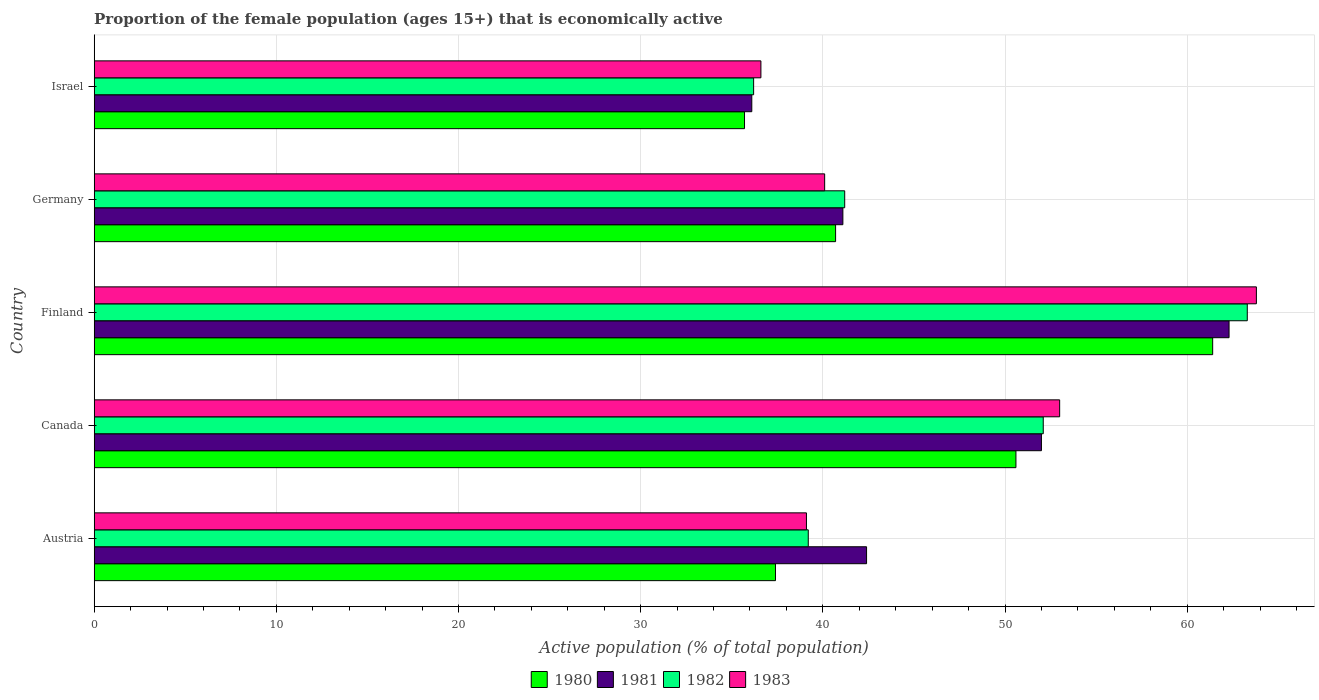How many different coloured bars are there?
Give a very brief answer. 4. Are the number of bars per tick equal to the number of legend labels?
Give a very brief answer. Yes. Are the number of bars on each tick of the Y-axis equal?
Provide a succinct answer. Yes. How many bars are there on the 2nd tick from the bottom?
Give a very brief answer. 4. What is the label of the 5th group of bars from the top?
Your answer should be compact. Austria. In how many cases, is the number of bars for a given country not equal to the number of legend labels?
Your answer should be compact. 0. What is the proportion of the female population that is economically active in 1983 in Germany?
Ensure brevity in your answer.  40.1. Across all countries, what is the maximum proportion of the female population that is economically active in 1981?
Ensure brevity in your answer.  62.3. Across all countries, what is the minimum proportion of the female population that is economically active in 1982?
Your response must be concise. 36.2. In which country was the proportion of the female population that is economically active in 1983 maximum?
Your answer should be very brief. Finland. In which country was the proportion of the female population that is economically active in 1983 minimum?
Provide a short and direct response. Israel. What is the total proportion of the female population that is economically active in 1982 in the graph?
Ensure brevity in your answer.  232. What is the difference between the proportion of the female population that is economically active in 1983 in Austria and that in Finland?
Give a very brief answer. -24.7. What is the difference between the proportion of the female population that is economically active in 1983 in Israel and the proportion of the female population that is economically active in 1981 in Canada?
Provide a succinct answer. -15.4. What is the average proportion of the female population that is economically active in 1983 per country?
Your answer should be very brief. 46.52. What is the ratio of the proportion of the female population that is economically active in 1981 in Canada to that in Finland?
Keep it short and to the point. 0.83. Is the difference between the proportion of the female population that is economically active in 1980 in Finland and Israel greater than the difference between the proportion of the female population that is economically active in 1981 in Finland and Israel?
Your answer should be very brief. No. What is the difference between the highest and the second highest proportion of the female population that is economically active in 1981?
Your answer should be compact. 10.3. What is the difference between the highest and the lowest proportion of the female population that is economically active in 1981?
Give a very brief answer. 26.2. In how many countries, is the proportion of the female population that is economically active in 1982 greater than the average proportion of the female population that is economically active in 1982 taken over all countries?
Your answer should be compact. 2. Is the sum of the proportion of the female population that is economically active in 1980 in Canada and Germany greater than the maximum proportion of the female population that is economically active in 1981 across all countries?
Your answer should be very brief. Yes. Is it the case that in every country, the sum of the proportion of the female population that is economically active in 1983 and proportion of the female population that is economically active in 1981 is greater than the sum of proportion of the female population that is economically active in 1982 and proportion of the female population that is economically active in 1980?
Your response must be concise. No. What does the 2nd bar from the bottom in Austria represents?
Keep it short and to the point. 1981. Are all the bars in the graph horizontal?
Provide a succinct answer. Yes. Does the graph contain grids?
Provide a succinct answer. Yes. What is the title of the graph?
Your response must be concise. Proportion of the female population (ages 15+) that is economically active. Does "2009" appear as one of the legend labels in the graph?
Provide a succinct answer. No. What is the label or title of the X-axis?
Offer a terse response. Active population (% of total population). What is the label or title of the Y-axis?
Your answer should be compact. Country. What is the Active population (% of total population) of 1980 in Austria?
Keep it short and to the point. 37.4. What is the Active population (% of total population) in 1981 in Austria?
Offer a terse response. 42.4. What is the Active population (% of total population) of 1982 in Austria?
Offer a very short reply. 39.2. What is the Active population (% of total population) in 1983 in Austria?
Your answer should be very brief. 39.1. What is the Active population (% of total population) of 1980 in Canada?
Make the answer very short. 50.6. What is the Active population (% of total population) of 1981 in Canada?
Give a very brief answer. 52. What is the Active population (% of total population) of 1982 in Canada?
Give a very brief answer. 52.1. What is the Active population (% of total population) in 1983 in Canada?
Your answer should be very brief. 53. What is the Active population (% of total population) in 1980 in Finland?
Give a very brief answer. 61.4. What is the Active population (% of total population) in 1981 in Finland?
Make the answer very short. 62.3. What is the Active population (% of total population) of 1982 in Finland?
Keep it short and to the point. 63.3. What is the Active population (% of total population) of 1983 in Finland?
Your answer should be compact. 63.8. What is the Active population (% of total population) of 1980 in Germany?
Your answer should be compact. 40.7. What is the Active population (% of total population) of 1981 in Germany?
Make the answer very short. 41.1. What is the Active population (% of total population) of 1982 in Germany?
Give a very brief answer. 41.2. What is the Active population (% of total population) of 1983 in Germany?
Your answer should be compact. 40.1. What is the Active population (% of total population) of 1980 in Israel?
Your response must be concise. 35.7. What is the Active population (% of total population) of 1981 in Israel?
Your answer should be very brief. 36.1. What is the Active population (% of total population) in 1982 in Israel?
Ensure brevity in your answer.  36.2. What is the Active population (% of total population) of 1983 in Israel?
Your answer should be compact. 36.6. Across all countries, what is the maximum Active population (% of total population) of 1980?
Offer a terse response. 61.4. Across all countries, what is the maximum Active population (% of total population) of 1981?
Make the answer very short. 62.3. Across all countries, what is the maximum Active population (% of total population) of 1982?
Your response must be concise. 63.3. Across all countries, what is the maximum Active population (% of total population) of 1983?
Provide a succinct answer. 63.8. Across all countries, what is the minimum Active population (% of total population) in 1980?
Keep it short and to the point. 35.7. Across all countries, what is the minimum Active population (% of total population) in 1981?
Your answer should be compact. 36.1. Across all countries, what is the minimum Active population (% of total population) of 1982?
Offer a very short reply. 36.2. Across all countries, what is the minimum Active population (% of total population) in 1983?
Your response must be concise. 36.6. What is the total Active population (% of total population) in 1980 in the graph?
Give a very brief answer. 225.8. What is the total Active population (% of total population) in 1981 in the graph?
Your response must be concise. 233.9. What is the total Active population (% of total population) in 1982 in the graph?
Keep it short and to the point. 232. What is the total Active population (% of total population) in 1983 in the graph?
Provide a short and direct response. 232.6. What is the difference between the Active population (% of total population) of 1980 in Austria and that in Canada?
Your answer should be compact. -13.2. What is the difference between the Active population (% of total population) in 1982 in Austria and that in Canada?
Provide a short and direct response. -12.9. What is the difference between the Active population (% of total population) in 1980 in Austria and that in Finland?
Keep it short and to the point. -24. What is the difference between the Active population (% of total population) in 1981 in Austria and that in Finland?
Your answer should be compact. -19.9. What is the difference between the Active population (% of total population) of 1982 in Austria and that in Finland?
Give a very brief answer. -24.1. What is the difference between the Active population (% of total population) of 1983 in Austria and that in Finland?
Offer a very short reply. -24.7. What is the difference between the Active population (% of total population) of 1982 in Austria and that in Germany?
Ensure brevity in your answer.  -2. What is the difference between the Active population (% of total population) in 1980 in Austria and that in Israel?
Offer a terse response. 1.7. What is the difference between the Active population (% of total population) of 1981 in Austria and that in Israel?
Keep it short and to the point. 6.3. What is the difference between the Active population (% of total population) of 1980 in Canada and that in Finland?
Your answer should be very brief. -10.8. What is the difference between the Active population (% of total population) in 1983 in Canada and that in Finland?
Give a very brief answer. -10.8. What is the difference between the Active population (% of total population) of 1981 in Canada and that in Germany?
Ensure brevity in your answer.  10.9. What is the difference between the Active population (% of total population) in 1983 in Canada and that in Germany?
Provide a succinct answer. 12.9. What is the difference between the Active population (% of total population) of 1980 in Canada and that in Israel?
Provide a short and direct response. 14.9. What is the difference between the Active population (% of total population) in 1982 in Canada and that in Israel?
Keep it short and to the point. 15.9. What is the difference between the Active population (% of total population) of 1983 in Canada and that in Israel?
Offer a terse response. 16.4. What is the difference between the Active population (% of total population) in 1980 in Finland and that in Germany?
Offer a terse response. 20.7. What is the difference between the Active population (% of total population) in 1981 in Finland and that in Germany?
Make the answer very short. 21.2. What is the difference between the Active population (% of total population) in 1982 in Finland and that in Germany?
Give a very brief answer. 22.1. What is the difference between the Active population (% of total population) in 1983 in Finland and that in Germany?
Keep it short and to the point. 23.7. What is the difference between the Active population (% of total population) in 1980 in Finland and that in Israel?
Keep it short and to the point. 25.7. What is the difference between the Active population (% of total population) in 1981 in Finland and that in Israel?
Make the answer very short. 26.2. What is the difference between the Active population (% of total population) in 1982 in Finland and that in Israel?
Offer a terse response. 27.1. What is the difference between the Active population (% of total population) of 1983 in Finland and that in Israel?
Give a very brief answer. 27.2. What is the difference between the Active population (% of total population) in 1981 in Germany and that in Israel?
Your answer should be very brief. 5. What is the difference between the Active population (% of total population) of 1980 in Austria and the Active population (% of total population) of 1981 in Canada?
Make the answer very short. -14.6. What is the difference between the Active population (% of total population) in 1980 in Austria and the Active population (% of total population) in 1982 in Canada?
Provide a succinct answer. -14.7. What is the difference between the Active population (% of total population) in 1980 in Austria and the Active population (% of total population) in 1983 in Canada?
Provide a succinct answer. -15.6. What is the difference between the Active population (% of total population) of 1981 in Austria and the Active population (% of total population) of 1983 in Canada?
Keep it short and to the point. -10.6. What is the difference between the Active population (% of total population) of 1980 in Austria and the Active population (% of total population) of 1981 in Finland?
Keep it short and to the point. -24.9. What is the difference between the Active population (% of total population) of 1980 in Austria and the Active population (% of total population) of 1982 in Finland?
Your answer should be very brief. -25.9. What is the difference between the Active population (% of total population) of 1980 in Austria and the Active population (% of total population) of 1983 in Finland?
Make the answer very short. -26.4. What is the difference between the Active population (% of total population) of 1981 in Austria and the Active population (% of total population) of 1982 in Finland?
Your answer should be very brief. -20.9. What is the difference between the Active population (% of total population) in 1981 in Austria and the Active population (% of total population) in 1983 in Finland?
Your answer should be compact. -21.4. What is the difference between the Active population (% of total population) in 1982 in Austria and the Active population (% of total population) in 1983 in Finland?
Your answer should be very brief. -24.6. What is the difference between the Active population (% of total population) in 1980 in Austria and the Active population (% of total population) in 1981 in Germany?
Ensure brevity in your answer.  -3.7. What is the difference between the Active population (% of total population) in 1980 in Austria and the Active population (% of total population) in 1983 in Germany?
Give a very brief answer. -2.7. What is the difference between the Active population (% of total population) in 1981 in Austria and the Active population (% of total population) in 1982 in Germany?
Keep it short and to the point. 1.2. What is the difference between the Active population (% of total population) of 1981 in Austria and the Active population (% of total population) of 1983 in Germany?
Make the answer very short. 2.3. What is the difference between the Active population (% of total population) of 1982 in Austria and the Active population (% of total population) of 1983 in Germany?
Make the answer very short. -0.9. What is the difference between the Active population (% of total population) of 1980 in Austria and the Active population (% of total population) of 1981 in Israel?
Offer a terse response. 1.3. What is the difference between the Active population (% of total population) in 1980 in Austria and the Active population (% of total population) in 1982 in Israel?
Provide a short and direct response. 1.2. What is the difference between the Active population (% of total population) in 1982 in Austria and the Active population (% of total population) in 1983 in Israel?
Offer a terse response. 2.6. What is the difference between the Active population (% of total population) of 1980 in Canada and the Active population (% of total population) of 1981 in Finland?
Provide a short and direct response. -11.7. What is the difference between the Active population (% of total population) of 1980 in Canada and the Active population (% of total population) of 1982 in Finland?
Your answer should be very brief. -12.7. What is the difference between the Active population (% of total population) of 1980 in Canada and the Active population (% of total population) of 1983 in Finland?
Provide a succinct answer. -13.2. What is the difference between the Active population (% of total population) in 1981 in Canada and the Active population (% of total population) in 1982 in Finland?
Ensure brevity in your answer.  -11.3. What is the difference between the Active population (% of total population) in 1980 in Canada and the Active population (% of total population) in 1981 in Germany?
Keep it short and to the point. 9.5. What is the difference between the Active population (% of total population) in 1980 in Canada and the Active population (% of total population) in 1982 in Germany?
Offer a very short reply. 9.4. What is the difference between the Active population (% of total population) of 1980 in Canada and the Active population (% of total population) of 1983 in Germany?
Offer a terse response. 10.5. What is the difference between the Active population (% of total population) of 1981 in Canada and the Active population (% of total population) of 1983 in Germany?
Provide a short and direct response. 11.9. What is the difference between the Active population (% of total population) of 1980 in Canada and the Active population (% of total population) of 1981 in Israel?
Make the answer very short. 14.5. What is the difference between the Active population (% of total population) in 1980 in Canada and the Active population (% of total population) in 1982 in Israel?
Your answer should be compact. 14.4. What is the difference between the Active population (% of total population) in 1980 in Canada and the Active population (% of total population) in 1983 in Israel?
Keep it short and to the point. 14. What is the difference between the Active population (% of total population) of 1982 in Canada and the Active population (% of total population) of 1983 in Israel?
Give a very brief answer. 15.5. What is the difference between the Active population (% of total population) in 1980 in Finland and the Active population (% of total population) in 1981 in Germany?
Provide a short and direct response. 20.3. What is the difference between the Active population (% of total population) in 1980 in Finland and the Active population (% of total population) in 1982 in Germany?
Keep it short and to the point. 20.2. What is the difference between the Active population (% of total population) in 1980 in Finland and the Active population (% of total population) in 1983 in Germany?
Offer a terse response. 21.3. What is the difference between the Active population (% of total population) of 1981 in Finland and the Active population (% of total population) of 1982 in Germany?
Ensure brevity in your answer.  21.1. What is the difference between the Active population (% of total population) in 1981 in Finland and the Active population (% of total population) in 1983 in Germany?
Your response must be concise. 22.2. What is the difference between the Active population (% of total population) in 1982 in Finland and the Active population (% of total population) in 1983 in Germany?
Keep it short and to the point. 23.2. What is the difference between the Active population (% of total population) of 1980 in Finland and the Active population (% of total population) of 1981 in Israel?
Ensure brevity in your answer.  25.3. What is the difference between the Active population (% of total population) of 1980 in Finland and the Active population (% of total population) of 1982 in Israel?
Ensure brevity in your answer.  25.2. What is the difference between the Active population (% of total population) of 1980 in Finland and the Active population (% of total population) of 1983 in Israel?
Give a very brief answer. 24.8. What is the difference between the Active population (% of total population) of 1981 in Finland and the Active population (% of total population) of 1982 in Israel?
Make the answer very short. 26.1. What is the difference between the Active population (% of total population) in 1981 in Finland and the Active population (% of total population) in 1983 in Israel?
Your answer should be very brief. 25.7. What is the difference between the Active population (% of total population) in 1982 in Finland and the Active population (% of total population) in 1983 in Israel?
Keep it short and to the point. 26.7. What is the difference between the Active population (% of total population) of 1981 in Germany and the Active population (% of total population) of 1983 in Israel?
Your answer should be compact. 4.5. What is the difference between the Active population (% of total population) in 1982 in Germany and the Active population (% of total population) in 1983 in Israel?
Keep it short and to the point. 4.6. What is the average Active population (% of total population) of 1980 per country?
Offer a very short reply. 45.16. What is the average Active population (% of total population) of 1981 per country?
Provide a short and direct response. 46.78. What is the average Active population (% of total population) in 1982 per country?
Keep it short and to the point. 46.4. What is the average Active population (% of total population) in 1983 per country?
Your response must be concise. 46.52. What is the difference between the Active population (% of total population) in 1981 and Active population (% of total population) in 1982 in Austria?
Offer a terse response. 3.2. What is the difference between the Active population (% of total population) of 1981 and Active population (% of total population) of 1983 in Austria?
Your answer should be very brief. 3.3. What is the difference between the Active population (% of total population) in 1980 and Active population (% of total population) in 1981 in Canada?
Your answer should be very brief. -1.4. What is the difference between the Active population (% of total population) of 1981 and Active population (% of total population) of 1983 in Canada?
Offer a terse response. -1. What is the difference between the Active population (% of total population) of 1982 and Active population (% of total population) of 1983 in Canada?
Provide a short and direct response. -0.9. What is the difference between the Active population (% of total population) in 1981 and Active population (% of total population) in 1983 in Finland?
Make the answer very short. -1.5. What is the difference between the Active population (% of total population) in 1980 and Active population (% of total population) in 1981 in Germany?
Your response must be concise. -0.4. What is the difference between the Active population (% of total population) in 1980 and Active population (% of total population) in 1983 in Germany?
Your answer should be compact. 0.6. What is the difference between the Active population (% of total population) of 1981 and Active population (% of total population) of 1982 in Germany?
Offer a terse response. -0.1. What is the difference between the Active population (% of total population) in 1982 and Active population (% of total population) in 1983 in Germany?
Offer a very short reply. 1.1. What is the difference between the Active population (% of total population) of 1980 and Active population (% of total population) of 1983 in Israel?
Provide a short and direct response. -0.9. What is the difference between the Active population (% of total population) of 1981 and Active population (% of total population) of 1982 in Israel?
Your answer should be compact. -0.1. What is the difference between the Active population (% of total population) of 1981 and Active population (% of total population) of 1983 in Israel?
Your answer should be very brief. -0.5. What is the difference between the Active population (% of total population) in 1982 and Active population (% of total population) in 1983 in Israel?
Keep it short and to the point. -0.4. What is the ratio of the Active population (% of total population) in 1980 in Austria to that in Canada?
Make the answer very short. 0.74. What is the ratio of the Active population (% of total population) in 1981 in Austria to that in Canada?
Offer a very short reply. 0.82. What is the ratio of the Active population (% of total population) in 1982 in Austria to that in Canada?
Give a very brief answer. 0.75. What is the ratio of the Active population (% of total population) of 1983 in Austria to that in Canada?
Offer a very short reply. 0.74. What is the ratio of the Active population (% of total population) of 1980 in Austria to that in Finland?
Make the answer very short. 0.61. What is the ratio of the Active population (% of total population) of 1981 in Austria to that in Finland?
Provide a succinct answer. 0.68. What is the ratio of the Active population (% of total population) of 1982 in Austria to that in Finland?
Your answer should be compact. 0.62. What is the ratio of the Active population (% of total population) of 1983 in Austria to that in Finland?
Keep it short and to the point. 0.61. What is the ratio of the Active population (% of total population) of 1980 in Austria to that in Germany?
Your answer should be very brief. 0.92. What is the ratio of the Active population (% of total population) in 1981 in Austria to that in Germany?
Ensure brevity in your answer.  1.03. What is the ratio of the Active population (% of total population) in 1982 in Austria to that in Germany?
Offer a terse response. 0.95. What is the ratio of the Active population (% of total population) in 1983 in Austria to that in Germany?
Your answer should be very brief. 0.98. What is the ratio of the Active population (% of total population) in 1980 in Austria to that in Israel?
Give a very brief answer. 1.05. What is the ratio of the Active population (% of total population) in 1981 in Austria to that in Israel?
Ensure brevity in your answer.  1.17. What is the ratio of the Active population (% of total population) of 1982 in Austria to that in Israel?
Provide a short and direct response. 1.08. What is the ratio of the Active population (% of total population) of 1983 in Austria to that in Israel?
Provide a succinct answer. 1.07. What is the ratio of the Active population (% of total population) in 1980 in Canada to that in Finland?
Make the answer very short. 0.82. What is the ratio of the Active population (% of total population) in 1981 in Canada to that in Finland?
Give a very brief answer. 0.83. What is the ratio of the Active population (% of total population) in 1982 in Canada to that in Finland?
Ensure brevity in your answer.  0.82. What is the ratio of the Active population (% of total population) of 1983 in Canada to that in Finland?
Offer a very short reply. 0.83. What is the ratio of the Active population (% of total population) of 1980 in Canada to that in Germany?
Make the answer very short. 1.24. What is the ratio of the Active population (% of total population) of 1981 in Canada to that in Germany?
Give a very brief answer. 1.27. What is the ratio of the Active population (% of total population) of 1982 in Canada to that in Germany?
Your answer should be compact. 1.26. What is the ratio of the Active population (% of total population) of 1983 in Canada to that in Germany?
Provide a succinct answer. 1.32. What is the ratio of the Active population (% of total population) in 1980 in Canada to that in Israel?
Give a very brief answer. 1.42. What is the ratio of the Active population (% of total population) in 1981 in Canada to that in Israel?
Your response must be concise. 1.44. What is the ratio of the Active population (% of total population) of 1982 in Canada to that in Israel?
Offer a very short reply. 1.44. What is the ratio of the Active population (% of total population) of 1983 in Canada to that in Israel?
Your answer should be compact. 1.45. What is the ratio of the Active population (% of total population) of 1980 in Finland to that in Germany?
Ensure brevity in your answer.  1.51. What is the ratio of the Active population (% of total population) in 1981 in Finland to that in Germany?
Offer a terse response. 1.52. What is the ratio of the Active population (% of total population) of 1982 in Finland to that in Germany?
Keep it short and to the point. 1.54. What is the ratio of the Active population (% of total population) in 1983 in Finland to that in Germany?
Provide a short and direct response. 1.59. What is the ratio of the Active population (% of total population) in 1980 in Finland to that in Israel?
Your answer should be compact. 1.72. What is the ratio of the Active population (% of total population) of 1981 in Finland to that in Israel?
Your response must be concise. 1.73. What is the ratio of the Active population (% of total population) of 1982 in Finland to that in Israel?
Make the answer very short. 1.75. What is the ratio of the Active population (% of total population) of 1983 in Finland to that in Israel?
Provide a short and direct response. 1.74. What is the ratio of the Active population (% of total population) in 1980 in Germany to that in Israel?
Keep it short and to the point. 1.14. What is the ratio of the Active population (% of total population) of 1981 in Germany to that in Israel?
Your answer should be very brief. 1.14. What is the ratio of the Active population (% of total population) in 1982 in Germany to that in Israel?
Offer a terse response. 1.14. What is the ratio of the Active population (% of total population) in 1983 in Germany to that in Israel?
Your answer should be compact. 1.1. What is the difference between the highest and the second highest Active population (% of total population) in 1980?
Make the answer very short. 10.8. What is the difference between the highest and the second highest Active population (% of total population) of 1982?
Provide a short and direct response. 11.2. What is the difference between the highest and the lowest Active population (% of total population) in 1980?
Provide a succinct answer. 25.7. What is the difference between the highest and the lowest Active population (% of total population) of 1981?
Keep it short and to the point. 26.2. What is the difference between the highest and the lowest Active population (% of total population) in 1982?
Offer a very short reply. 27.1. What is the difference between the highest and the lowest Active population (% of total population) in 1983?
Give a very brief answer. 27.2. 